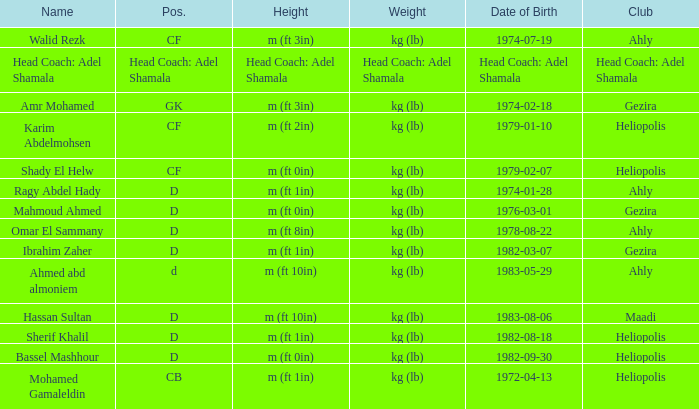What is Date of Birth, when Height is "Head Coach: Adel Shamala"? Head Coach: Adel Shamala. 